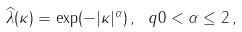<formula> <loc_0><loc_0><loc_500><loc_500>\widehat { \lambda } ( \kappa ) = \exp ( - | \kappa | ^ { \alpha } ) \, , \ q 0 < \alpha \leq 2 \, ,</formula> 